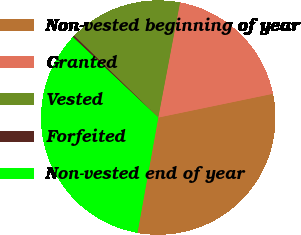Convert chart. <chart><loc_0><loc_0><loc_500><loc_500><pie_chart><fcel>Non-vested beginning of year<fcel>Granted<fcel>Vested<fcel>Forfeited<fcel>Non-vested end of year<nl><fcel>31.1%<fcel>18.77%<fcel>15.68%<fcel>0.27%<fcel>34.18%<nl></chart> 